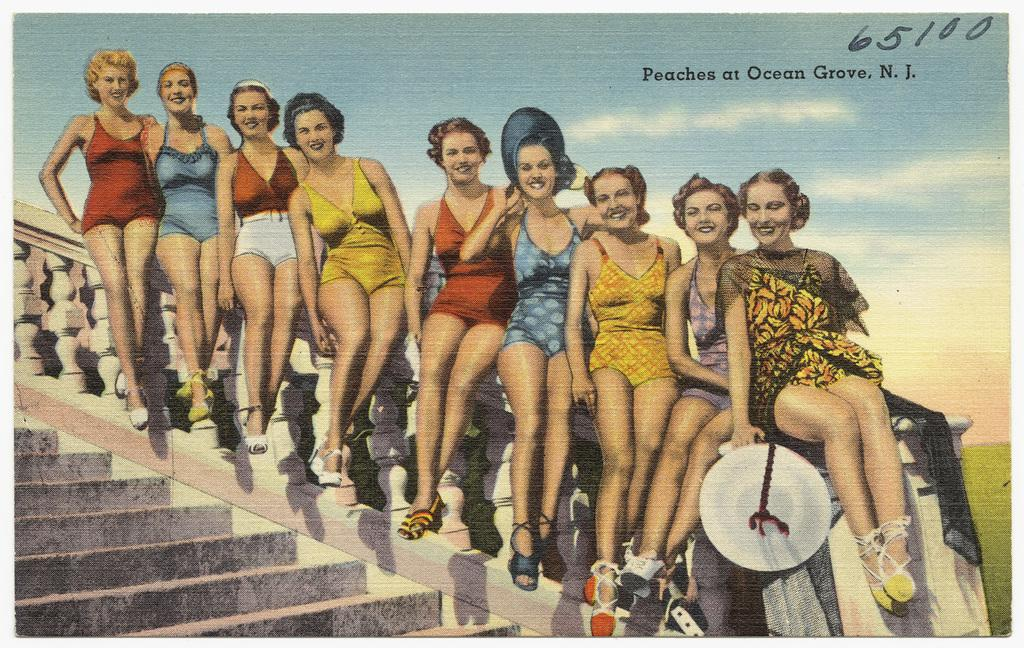What are the women in the image doing? The women are sitting on the railing in the image. Is there any text visible in the image? Yes, there is some text visible on the top right side of the image. What can be seen in the background of the image? There are clouds in the sky in the background of the image. Can you describe the locket that the robin is wearing in the image? There is no locket or robin present in the image. What type of truck can be seen driving by in the image? There is no truck visible in the image. 